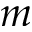Convert formula to latex. <formula><loc_0><loc_0><loc_500><loc_500>m</formula> 